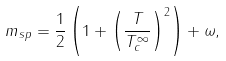<formula> <loc_0><loc_0><loc_500><loc_500>m _ { s p } = \frac { 1 } { 2 } \left ( 1 + \left ( \frac { T } { T _ { c } ^ { \infty } } \right ) ^ { 2 } \right ) + \omega ,</formula> 